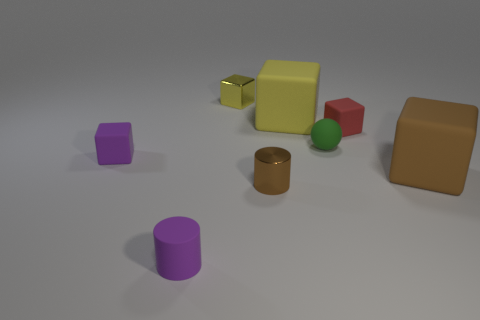There is a purple object in front of the brown thing that is behind the brown object in front of the big brown rubber block; what is its material?
Keep it short and to the point. Rubber. Is there anything else that has the same shape as the green matte object?
Give a very brief answer. No. There is a block left of the tiny yellow thing; does it have the same color as the tiny cylinder to the left of the metallic block?
Provide a short and direct response. Yes. There is a cube that is both in front of the tiny red matte thing and behind the brown cube; what is it made of?
Your response must be concise. Rubber. There is a big object that is right of the large yellow rubber thing; does it have the same shape as the big object on the left side of the red cube?
Provide a short and direct response. Yes. The thing that is the same color as the small matte cylinder is what shape?
Give a very brief answer. Cube. How many things are either cylinders that are right of the tiny yellow object or big green spheres?
Give a very brief answer. 1. Is the size of the rubber sphere the same as the brown cube?
Keep it short and to the point. No. What is the color of the cylinder that is to the left of the tiny brown metallic thing?
Offer a very short reply. Purple. What is the size of the purple block that is made of the same material as the small green object?
Offer a terse response. Small. 